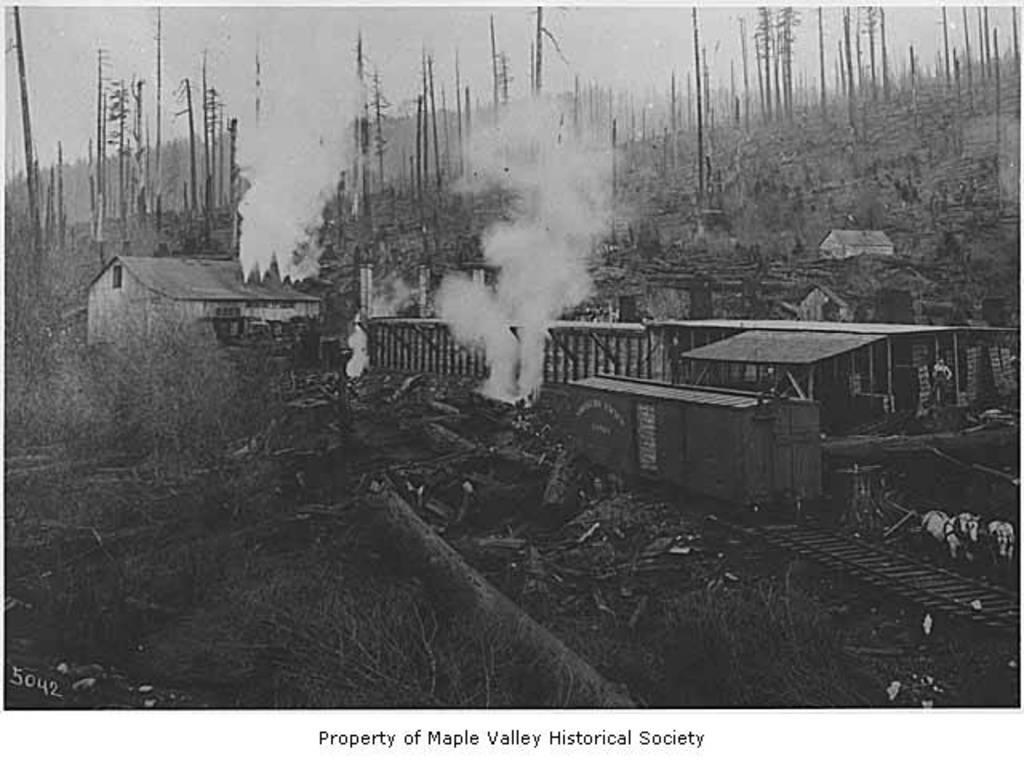Describe this image in one or two sentences. This is a black and white image, in this image in the center there is a train and house and some dog is coming out from the train. At the bottom there are some plants and grass, in the background there are some trees and poles and at the bottom of the image there is some text. 